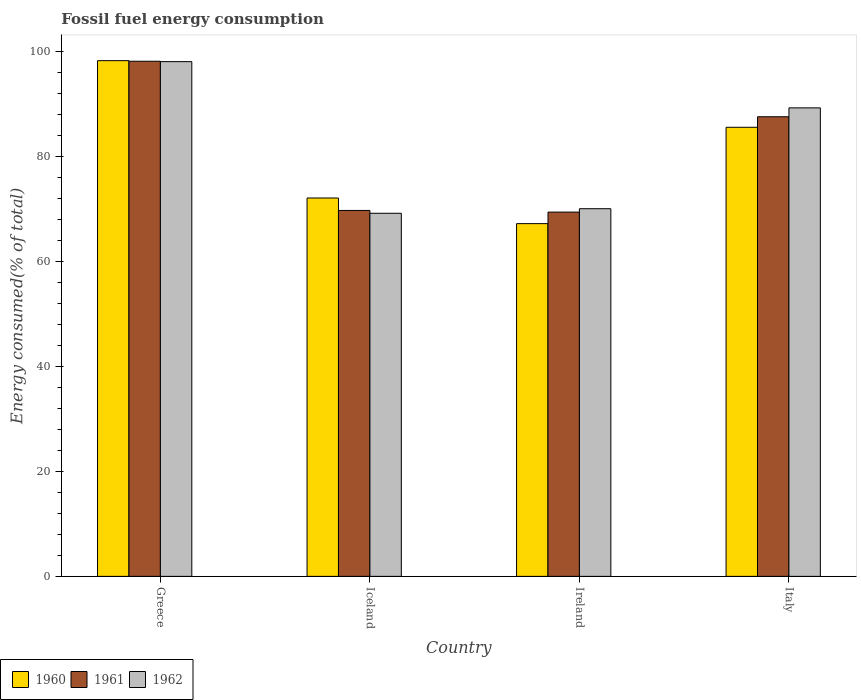How many groups of bars are there?
Ensure brevity in your answer.  4. Are the number of bars per tick equal to the number of legend labels?
Provide a short and direct response. Yes. How many bars are there on the 2nd tick from the right?
Provide a succinct answer. 3. What is the label of the 1st group of bars from the left?
Provide a short and direct response. Greece. What is the percentage of energy consumed in 1962 in Greece?
Ensure brevity in your answer.  98.12. Across all countries, what is the maximum percentage of energy consumed in 1960?
Your answer should be compact. 98.31. Across all countries, what is the minimum percentage of energy consumed in 1961?
Your answer should be very brief. 69.44. In which country was the percentage of energy consumed in 1960 minimum?
Provide a short and direct response. Ireland. What is the total percentage of energy consumed in 1961 in the graph?
Offer a very short reply. 325.01. What is the difference between the percentage of energy consumed in 1960 in Greece and that in Italy?
Ensure brevity in your answer.  12.7. What is the difference between the percentage of energy consumed in 1960 in Greece and the percentage of energy consumed in 1961 in Ireland?
Provide a succinct answer. 28.87. What is the average percentage of energy consumed in 1962 per country?
Offer a terse response. 81.68. What is the difference between the percentage of energy consumed of/in 1960 and percentage of energy consumed of/in 1962 in Ireland?
Make the answer very short. -2.84. What is the ratio of the percentage of energy consumed in 1960 in Greece to that in Italy?
Your answer should be very brief. 1.15. Is the difference between the percentage of energy consumed in 1960 in Iceland and Italy greater than the difference between the percentage of energy consumed in 1962 in Iceland and Italy?
Give a very brief answer. Yes. What is the difference between the highest and the second highest percentage of energy consumed in 1960?
Make the answer very short. -26.18. What is the difference between the highest and the lowest percentage of energy consumed in 1961?
Provide a succinct answer. 28.76. Is the sum of the percentage of energy consumed in 1962 in Greece and Italy greater than the maximum percentage of energy consumed in 1961 across all countries?
Make the answer very short. Yes. What does the 2nd bar from the left in Italy represents?
Offer a terse response. 1961. What does the 2nd bar from the right in Greece represents?
Make the answer very short. 1961. Is it the case that in every country, the sum of the percentage of energy consumed in 1962 and percentage of energy consumed in 1961 is greater than the percentage of energy consumed in 1960?
Offer a terse response. Yes. How many countries are there in the graph?
Make the answer very short. 4. What is the difference between two consecutive major ticks on the Y-axis?
Provide a short and direct response. 20. Where does the legend appear in the graph?
Your answer should be compact. Bottom left. How many legend labels are there?
Ensure brevity in your answer.  3. What is the title of the graph?
Keep it short and to the point. Fossil fuel energy consumption. Does "2014" appear as one of the legend labels in the graph?
Provide a short and direct response. No. What is the label or title of the X-axis?
Your response must be concise. Country. What is the label or title of the Y-axis?
Ensure brevity in your answer.  Energy consumed(% of total). What is the Energy consumed(% of total) of 1960 in Greece?
Offer a terse response. 98.31. What is the Energy consumed(% of total) of 1961 in Greece?
Offer a very short reply. 98.2. What is the Energy consumed(% of total) of 1962 in Greece?
Ensure brevity in your answer.  98.12. What is the Energy consumed(% of total) in 1960 in Iceland?
Ensure brevity in your answer.  72.13. What is the Energy consumed(% of total) in 1961 in Iceland?
Provide a succinct answer. 69.76. What is the Energy consumed(% of total) of 1962 in Iceland?
Your response must be concise. 69.22. What is the Energy consumed(% of total) in 1960 in Ireland?
Your answer should be very brief. 67.24. What is the Energy consumed(% of total) in 1961 in Ireland?
Ensure brevity in your answer.  69.44. What is the Energy consumed(% of total) of 1962 in Ireland?
Your response must be concise. 70.09. What is the Energy consumed(% of total) of 1960 in Italy?
Provide a succinct answer. 85.61. What is the Energy consumed(% of total) in 1961 in Italy?
Make the answer very short. 87.62. What is the Energy consumed(% of total) of 1962 in Italy?
Keep it short and to the point. 89.31. Across all countries, what is the maximum Energy consumed(% of total) of 1960?
Offer a terse response. 98.31. Across all countries, what is the maximum Energy consumed(% of total) in 1961?
Provide a succinct answer. 98.2. Across all countries, what is the maximum Energy consumed(% of total) in 1962?
Keep it short and to the point. 98.12. Across all countries, what is the minimum Energy consumed(% of total) in 1960?
Provide a short and direct response. 67.24. Across all countries, what is the minimum Energy consumed(% of total) in 1961?
Offer a terse response. 69.44. Across all countries, what is the minimum Energy consumed(% of total) of 1962?
Your response must be concise. 69.22. What is the total Energy consumed(% of total) in 1960 in the graph?
Ensure brevity in your answer.  323.29. What is the total Energy consumed(% of total) in 1961 in the graph?
Offer a terse response. 325.01. What is the total Energy consumed(% of total) of 1962 in the graph?
Give a very brief answer. 326.74. What is the difference between the Energy consumed(% of total) of 1960 in Greece and that in Iceland?
Your response must be concise. 26.18. What is the difference between the Energy consumed(% of total) in 1961 in Greece and that in Iceland?
Provide a succinct answer. 28.44. What is the difference between the Energy consumed(% of total) of 1962 in Greece and that in Iceland?
Ensure brevity in your answer.  28.91. What is the difference between the Energy consumed(% of total) in 1960 in Greece and that in Ireland?
Offer a terse response. 31.07. What is the difference between the Energy consumed(% of total) in 1961 in Greece and that in Ireland?
Offer a terse response. 28.76. What is the difference between the Energy consumed(% of total) of 1962 in Greece and that in Ireland?
Provide a short and direct response. 28.04. What is the difference between the Energy consumed(% of total) in 1960 in Greece and that in Italy?
Give a very brief answer. 12.7. What is the difference between the Energy consumed(% of total) in 1961 in Greece and that in Italy?
Give a very brief answer. 10.58. What is the difference between the Energy consumed(% of total) of 1962 in Greece and that in Italy?
Keep it short and to the point. 8.81. What is the difference between the Energy consumed(% of total) in 1960 in Iceland and that in Ireland?
Provide a succinct answer. 4.89. What is the difference between the Energy consumed(% of total) of 1961 in Iceland and that in Ireland?
Offer a terse response. 0.32. What is the difference between the Energy consumed(% of total) in 1962 in Iceland and that in Ireland?
Give a very brief answer. -0.87. What is the difference between the Energy consumed(% of total) in 1960 in Iceland and that in Italy?
Give a very brief answer. -13.48. What is the difference between the Energy consumed(% of total) in 1961 in Iceland and that in Italy?
Keep it short and to the point. -17.86. What is the difference between the Energy consumed(% of total) in 1962 in Iceland and that in Italy?
Keep it short and to the point. -20.09. What is the difference between the Energy consumed(% of total) of 1960 in Ireland and that in Italy?
Your response must be concise. -18.37. What is the difference between the Energy consumed(% of total) in 1961 in Ireland and that in Italy?
Give a very brief answer. -18.18. What is the difference between the Energy consumed(% of total) in 1962 in Ireland and that in Italy?
Ensure brevity in your answer.  -19.23. What is the difference between the Energy consumed(% of total) in 1960 in Greece and the Energy consumed(% of total) in 1961 in Iceland?
Ensure brevity in your answer.  28.55. What is the difference between the Energy consumed(% of total) of 1960 in Greece and the Energy consumed(% of total) of 1962 in Iceland?
Provide a succinct answer. 29.09. What is the difference between the Energy consumed(% of total) in 1961 in Greece and the Energy consumed(% of total) in 1962 in Iceland?
Offer a very short reply. 28.98. What is the difference between the Energy consumed(% of total) in 1960 in Greece and the Energy consumed(% of total) in 1961 in Ireland?
Make the answer very short. 28.87. What is the difference between the Energy consumed(% of total) in 1960 in Greece and the Energy consumed(% of total) in 1962 in Ireland?
Offer a terse response. 28.23. What is the difference between the Energy consumed(% of total) in 1961 in Greece and the Energy consumed(% of total) in 1962 in Ireland?
Give a very brief answer. 28.11. What is the difference between the Energy consumed(% of total) of 1960 in Greece and the Energy consumed(% of total) of 1961 in Italy?
Keep it short and to the point. 10.69. What is the difference between the Energy consumed(% of total) in 1960 in Greece and the Energy consumed(% of total) in 1962 in Italy?
Provide a succinct answer. 9. What is the difference between the Energy consumed(% of total) in 1961 in Greece and the Energy consumed(% of total) in 1962 in Italy?
Make the answer very short. 8.89. What is the difference between the Energy consumed(% of total) in 1960 in Iceland and the Energy consumed(% of total) in 1961 in Ireland?
Provide a short and direct response. 2.69. What is the difference between the Energy consumed(% of total) in 1960 in Iceland and the Energy consumed(% of total) in 1962 in Ireland?
Provide a short and direct response. 2.04. What is the difference between the Energy consumed(% of total) in 1961 in Iceland and the Energy consumed(% of total) in 1962 in Ireland?
Your response must be concise. -0.33. What is the difference between the Energy consumed(% of total) in 1960 in Iceland and the Energy consumed(% of total) in 1961 in Italy?
Your answer should be very brief. -15.49. What is the difference between the Energy consumed(% of total) in 1960 in Iceland and the Energy consumed(% of total) in 1962 in Italy?
Ensure brevity in your answer.  -17.18. What is the difference between the Energy consumed(% of total) in 1961 in Iceland and the Energy consumed(% of total) in 1962 in Italy?
Give a very brief answer. -19.55. What is the difference between the Energy consumed(% of total) in 1960 in Ireland and the Energy consumed(% of total) in 1961 in Italy?
Offer a terse response. -20.38. What is the difference between the Energy consumed(% of total) of 1960 in Ireland and the Energy consumed(% of total) of 1962 in Italy?
Ensure brevity in your answer.  -22.07. What is the difference between the Energy consumed(% of total) in 1961 in Ireland and the Energy consumed(% of total) in 1962 in Italy?
Make the answer very short. -19.87. What is the average Energy consumed(% of total) in 1960 per country?
Your answer should be compact. 80.82. What is the average Energy consumed(% of total) of 1961 per country?
Offer a terse response. 81.25. What is the average Energy consumed(% of total) of 1962 per country?
Keep it short and to the point. 81.68. What is the difference between the Energy consumed(% of total) of 1960 and Energy consumed(% of total) of 1961 in Greece?
Your answer should be compact. 0.11. What is the difference between the Energy consumed(% of total) of 1960 and Energy consumed(% of total) of 1962 in Greece?
Ensure brevity in your answer.  0.19. What is the difference between the Energy consumed(% of total) of 1961 and Energy consumed(% of total) of 1962 in Greece?
Your answer should be compact. 0.07. What is the difference between the Energy consumed(% of total) in 1960 and Energy consumed(% of total) in 1961 in Iceland?
Provide a short and direct response. 2.37. What is the difference between the Energy consumed(% of total) of 1960 and Energy consumed(% of total) of 1962 in Iceland?
Make the answer very short. 2.91. What is the difference between the Energy consumed(% of total) of 1961 and Energy consumed(% of total) of 1962 in Iceland?
Provide a short and direct response. 0.54. What is the difference between the Energy consumed(% of total) in 1960 and Energy consumed(% of total) in 1961 in Ireland?
Offer a terse response. -2.2. What is the difference between the Energy consumed(% of total) of 1960 and Energy consumed(% of total) of 1962 in Ireland?
Your response must be concise. -2.84. What is the difference between the Energy consumed(% of total) in 1961 and Energy consumed(% of total) in 1962 in Ireland?
Your answer should be compact. -0.65. What is the difference between the Energy consumed(% of total) of 1960 and Energy consumed(% of total) of 1961 in Italy?
Provide a succinct answer. -2.01. What is the difference between the Energy consumed(% of total) of 1960 and Energy consumed(% of total) of 1962 in Italy?
Provide a succinct answer. -3.7. What is the difference between the Energy consumed(% of total) of 1961 and Energy consumed(% of total) of 1962 in Italy?
Provide a succinct answer. -1.69. What is the ratio of the Energy consumed(% of total) of 1960 in Greece to that in Iceland?
Your answer should be very brief. 1.36. What is the ratio of the Energy consumed(% of total) in 1961 in Greece to that in Iceland?
Make the answer very short. 1.41. What is the ratio of the Energy consumed(% of total) in 1962 in Greece to that in Iceland?
Provide a short and direct response. 1.42. What is the ratio of the Energy consumed(% of total) of 1960 in Greece to that in Ireland?
Offer a very short reply. 1.46. What is the ratio of the Energy consumed(% of total) of 1961 in Greece to that in Ireland?
Make the answer very short. 1.41. What is the ratio of the Energy consumed(% of total) of 1962 in Greece to that in Ireland?
Your answer should be compact. 1.4. What is the ratio of the Energy consumed(% of total) in 1960 in Greece to that in Italy?
Offer a terse response. 1.15. What is the ratio of the Energy consumed(% of total) of 1961 in Greece to that in Italy?
Offer a terse response. 1.12. What is the ratio of the Energy consumed(% of total) in 1962 in Greece to that in Italy?
Make the answer very short. 1.1. What is the ratio of the Energy consumed(% of total) in 1960 in Iceland to that in Ireland?
Keep it short and to the point. 1.07. What is the ratio of the Energy consumed(% of total) in 1962 in Iceland to that in Ireland?
Your answer should be compact. 0.99. What is the ratio of the Energy consumed(% of total) in 1960 in Iceland to that in Italy?
Ensure brevity in your answer.  0.84. What is the ratio of the Energy consumed(% of total) in 1961 in Iceland to that in Italy?
Keep it short and to the point. 0.8. What is the ratio of the Energy consumed(% of total) in 1962 in Iceland to that in Italy?
Your answer should be compact. 0.78. What is the ratio of the Energy consumed(% of total) in 1960 in Ireland to that in Italy?
Make the answer very short. 0.79. What is the ratio of the Energy consumed(% of total) in 1961 in Ireland to that in Italy?
Your response must be concise. 0.79. What is the ratio of the Energy consumed(% of total) in 1962 in Ireland to that in Italy?
Offer a very short reply. 0.78. What is the difference between the highest and the second highest Energy consumed(% of total) in 1960?
Ensure brevity in your answer.  12.7. What is the difference between the highest and the second highest Energy consumed(% of total) in 1961?
Provide a short and direct response. 10.58. What is the difference between the highest and the second highest Energy consumed(% of total) of 1962?
Provide a short and direct response. 8.81. What is the difference between the highest and the lowest Energy consumed(% of total) of 1960?
Your answer should be very brief. 31.07. What is the difference between the highest and the lowest Energy consumed(% of total) of 1961?
Offer a very short reply. 28.76. What is the difference between the highest and the lowest Energy consumed(% of total) in 1962?
Offer a terse response. 28.91. 